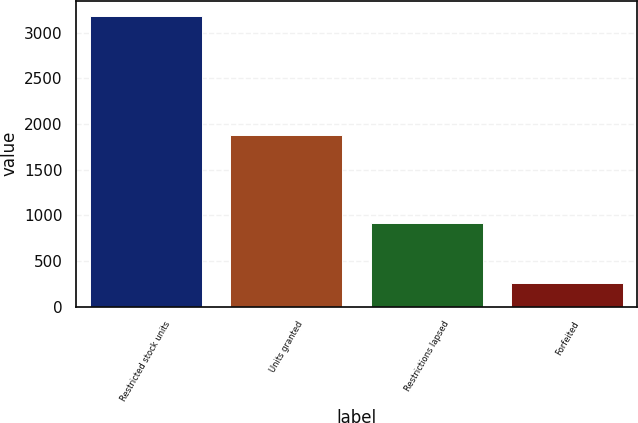Convert chart. <chart><loc_0><loc_0><loc_500><loc_500><bar_chart><fcel>Restricted stock units<fcel>Units granted<fcel>Restrictions lapsed<fcel>Forfeited<nl><fcel>3188<fcel>1876<fcel>920<fcel>261<nl></chart> 